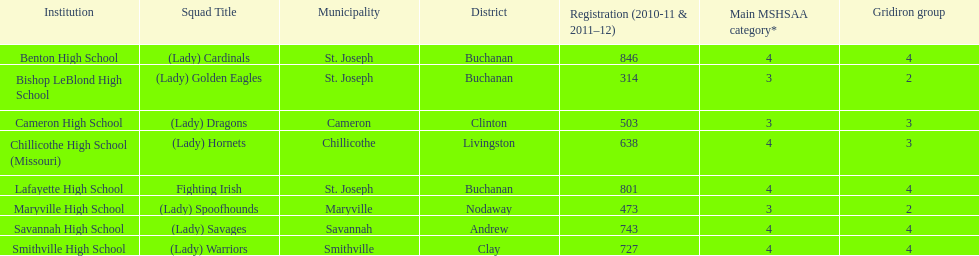Which schools are in the same town as bishop leblond? Benton High School, Lafayette High School. 